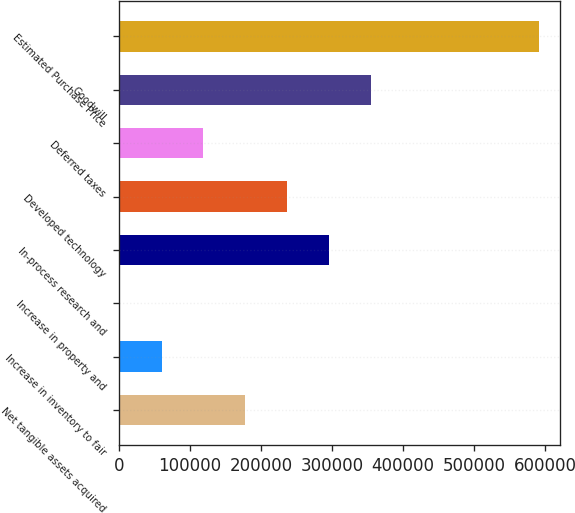<chart> <loc_0><loc_0><loc_500><loc_500><bar_chart><fcel>Net tangible assets acquired<fcel>Increase in inventory to fair<fcel>Increase in property and<fcel>In-process research and<fcel>Developed technology<fcel>Deferred taxes<fcel>Goodwill<fcel>Estimated Purchase Price<nl><fcel>177890<fcel>59830<fcel>800<fcel>295950<fcel>236920<fcel>118860<fcel>354980<fcel>591100<nl></chart> 